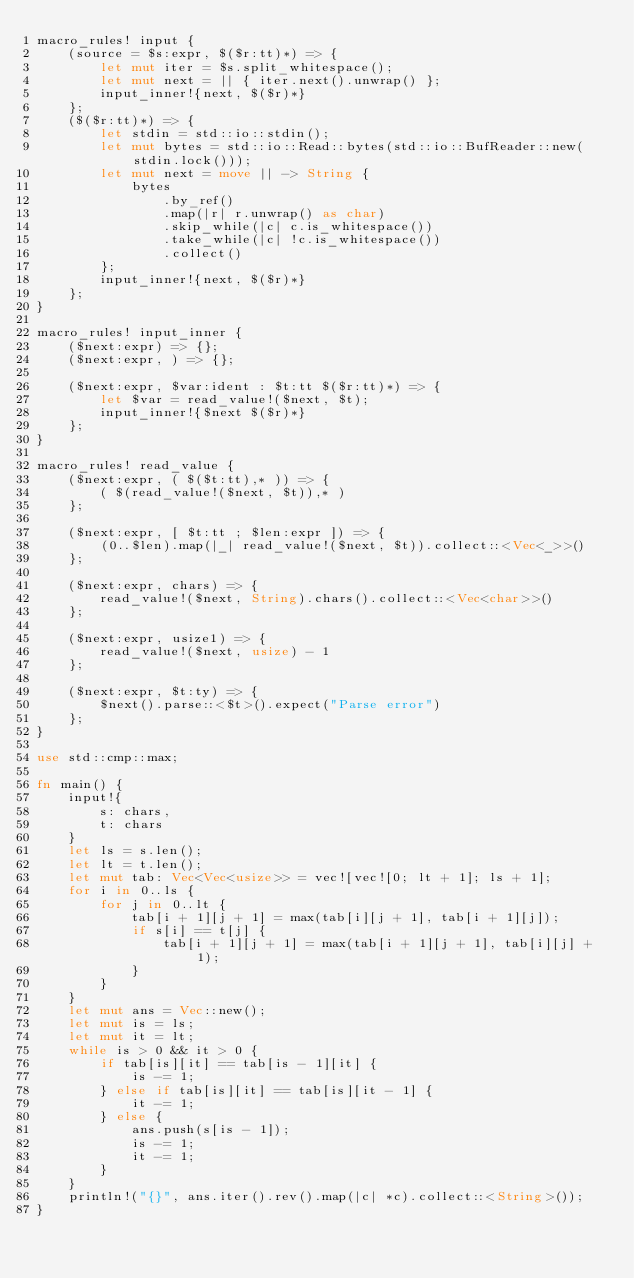<code> <loc_0><loc_0><loc_500><loc_500><_Rust_>macro_rules! input {
    (source = $s:expr, $($r:tt)*) => {
        let mut iter = $s.split_whitespace();
        let mut next = || { iter.next().unwrap() };
        input_inner!{next, $($r)*}
    };
    ($($r:tt)*) => {
        let stdin = std::io::stdin();
        let mut bytes = std::io::Read::bytes(std::io::BufReader::new(stdin.lock()));
        let mut next = move || -> String {
            bytes
                .by_ref()
                .map(|r| r.unwrap() as char)
                .skip_while(|c| c.is_whitespace())
                .take_while(|c| !c.is_whitespace())
                .collect()
        };
        input_inner!{next, $($r)*}
    };
}

macro_rules! input_inner {
    ($next:expr) => {};
    ($next:expr, ) => {};

    ($next:expr, $var:ident : $t:tt $($r:tt)*) => {
        let $var = read_value!($next, $t);
        input_inner!{$next $($r)*}
    };
}

macro_rules! read_value {
    ($next:expr, ( $($t:tt),* )) => {
        ( $(read_value!($next, $t)),* )
    };

    ($next:expr, [ $t:tt ; $len:expr ]) => {
        (0..$len).map(|_| read_value!($next, $t)).collect::<Vec<_>>()
    };

    ($next:expr, chars) => {
        read_value!($next, String).chars().collect::<Vec<char>>()
    };

    ($next:expr, usize1) => {
        read_value!($next, usize) - 1
    };

    ($next:expr, $t:ty) => {
        $next().parse::<$t>().expect("Parse error")
    };
}

use std::cmp::max;

fn main() {
    input!{
        s: chars,
        t: chars
    }
    let ls = s.len();
    let lt = t.len();
    let mut tab: Vec<Vec<usize>> = vec![vec![0; lt + 1]; ls + 1];
    for i in 0..ls {
        for j in 0..lt {
            tab[i + 1][j + 1] = max(tab[i][j + 1], tab[i + 1][j]);
            if s[i] == t[j] {
                tab[i + 1][j + 1] = max(tab[i + 1][j + 1], tab[i][j] + 1);
            }
        }
    }
    let mut ans = Vec::new();
    let mut is = ls;
    let mut it = lt;
    while is > 0 && it > 0 {
        if tab[is][it] == tab[is - 1][it] {
            is -= 1;
        } else if tab[is][it] == tab[is][it - 1] {
            it -= 1;
        } else {
            ans.push(s[is - 1]);
            is -= 1;
            it -= 1;
        }
    }
    println!("{}", ans.iter().rev().map(|c| *c).collect::<String>());
}
</code> 